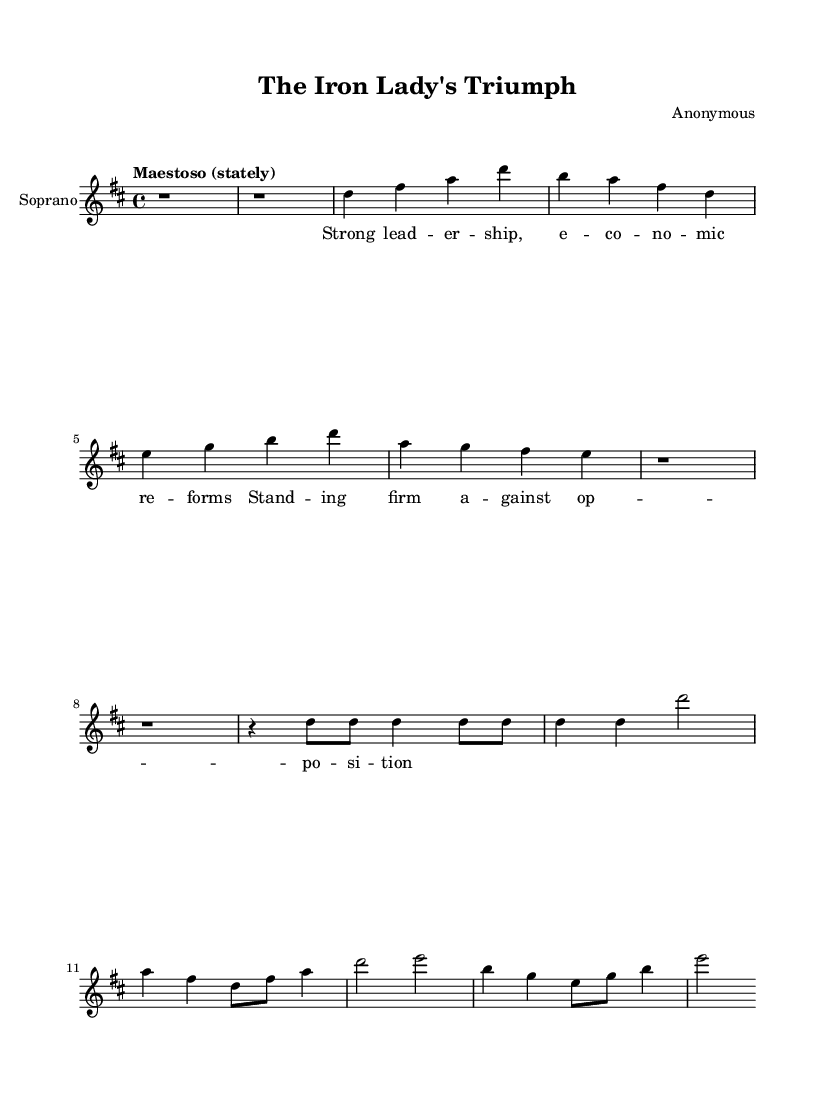What is the key signature of this music? The key signature of this music is D major, which is indicated by the two sharps (F# and C#) at the beginning of the staff.
Answer: D major What is the time signature of this music? The time signature is 4/4, as indicated by the numbers at the beginning, which means there are four beats in each measure.
Answer: 4/4 What is the tempo marking of this piece? The tempo marking is "Maestoso," which suggests a stately and dignified pace.
Answer: Maestoso How many measures are in the aria section? The aria section consists of four measures as seen in the notation following the introductory rests.
Answer: Four What are the prominent themes presented in the lyrics? The lyrics highlight leadership and economic reforms, suggesting a narrative tied to triumph in the face of opposition.
Answer: Leadership and reforms What type of voice is indicated for this piece? The voice type indicated is "Soprano," which is noted within the score for the instrument name.
Answer: Soprano What is the dynamic for the triumphant finale section? There is no specific dynamic marking shown in the snippet provided, but typically pieces with this theme may be marked with dynamic emphasis such as "forte."
Answer: Forte 